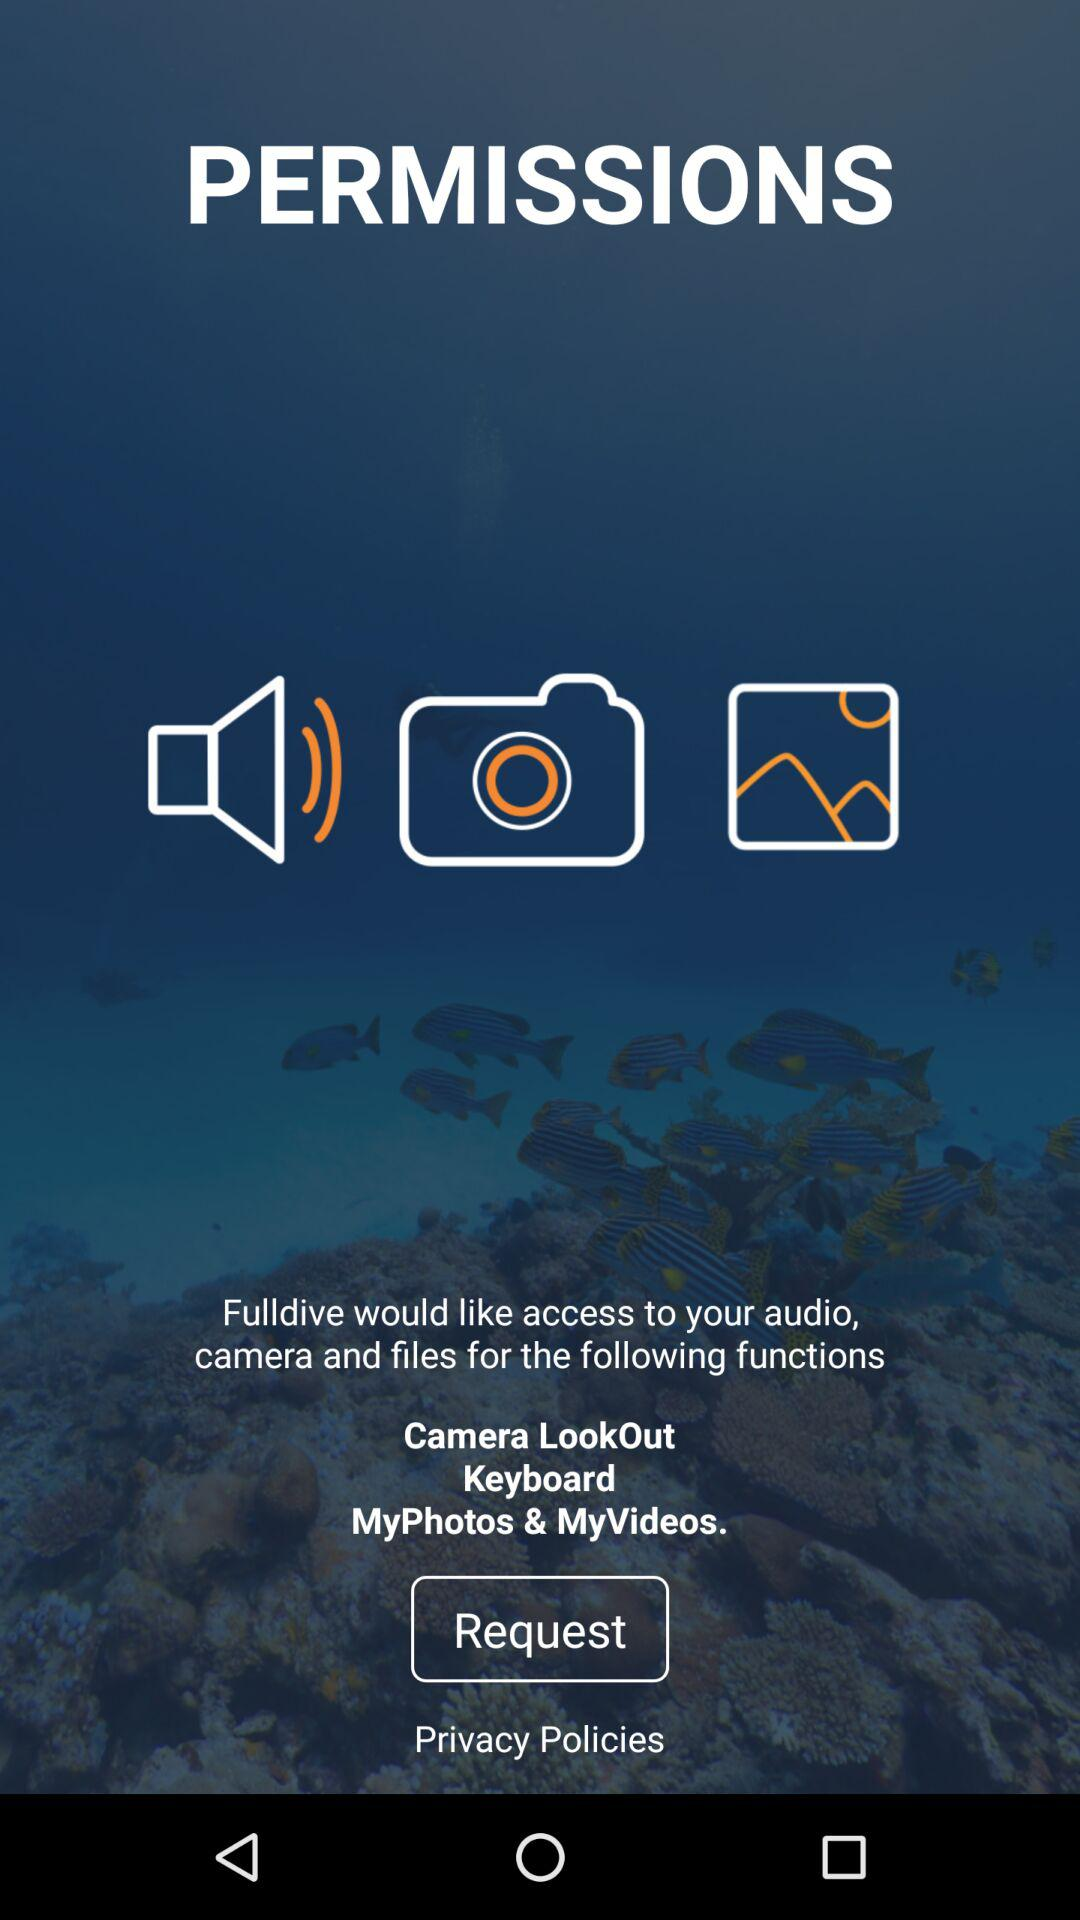How many permissions are being requested?
Answer the question using a single word or phrase. 3 